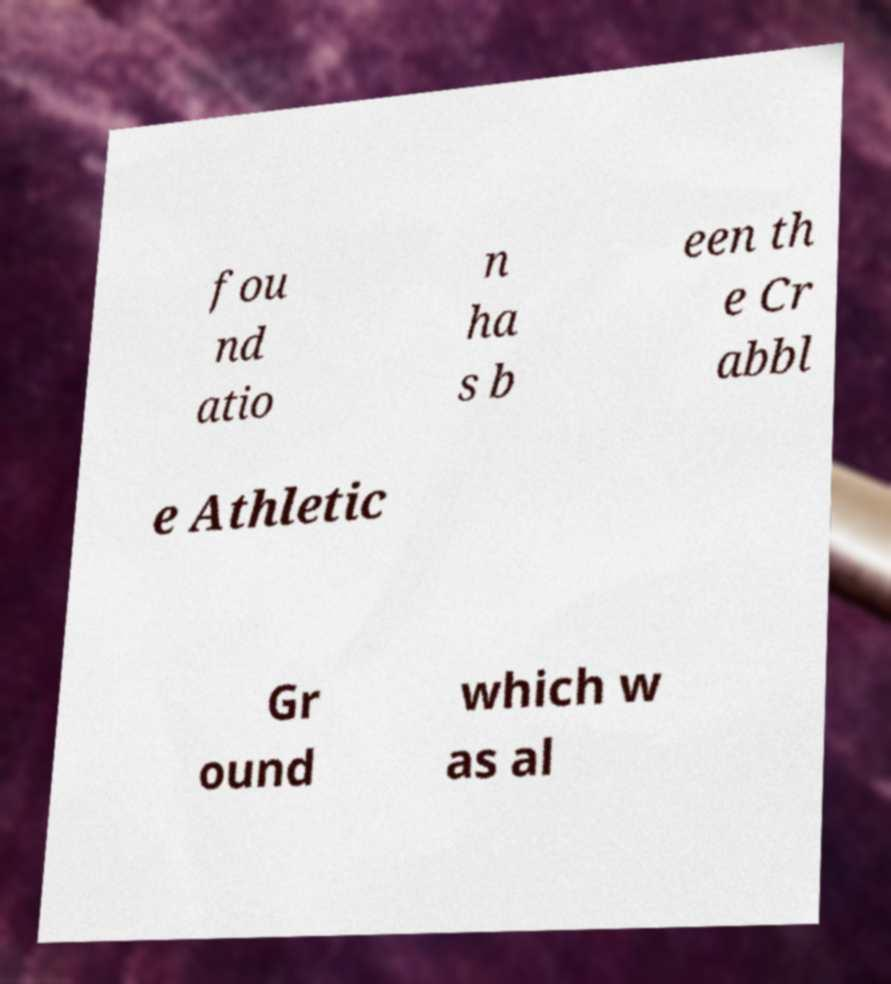For documentation purposes, I need the text within this image transcribed. Could you provide that? fou nd atio n ha s b een th e Cr abbl e Athletic Gr ound which w as al 